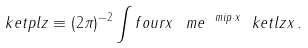Convert formula to latex. <formula><loc_0><loc_0><loc_500><loc_500>\ k e t p l z \equiv ( 2 \pi ) ^ { - 2 } \int f o u r x \, \ m e ^ { \ m i p \cdot x } \ k e t l z { x } \, .</formula> 